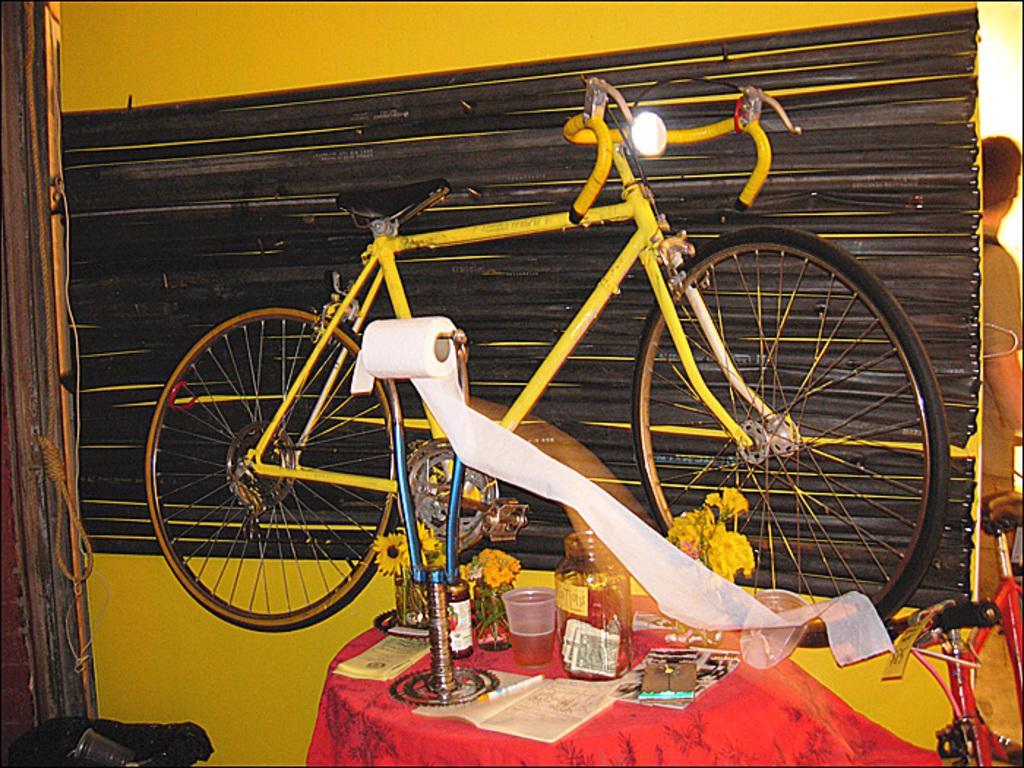Please provide a concise description of this image. In this image there is a bicycle attached to the wall. Right bottom there is a table having a stand, flower vases, glass, jar, book and few objects on it. A paper roll is on the stand. The glass is filled with drink. Right side there is a bicycle. Behind there is a person standing. Left bottom there is a table having a glass. Behind there is a rope hanging from the wall. 